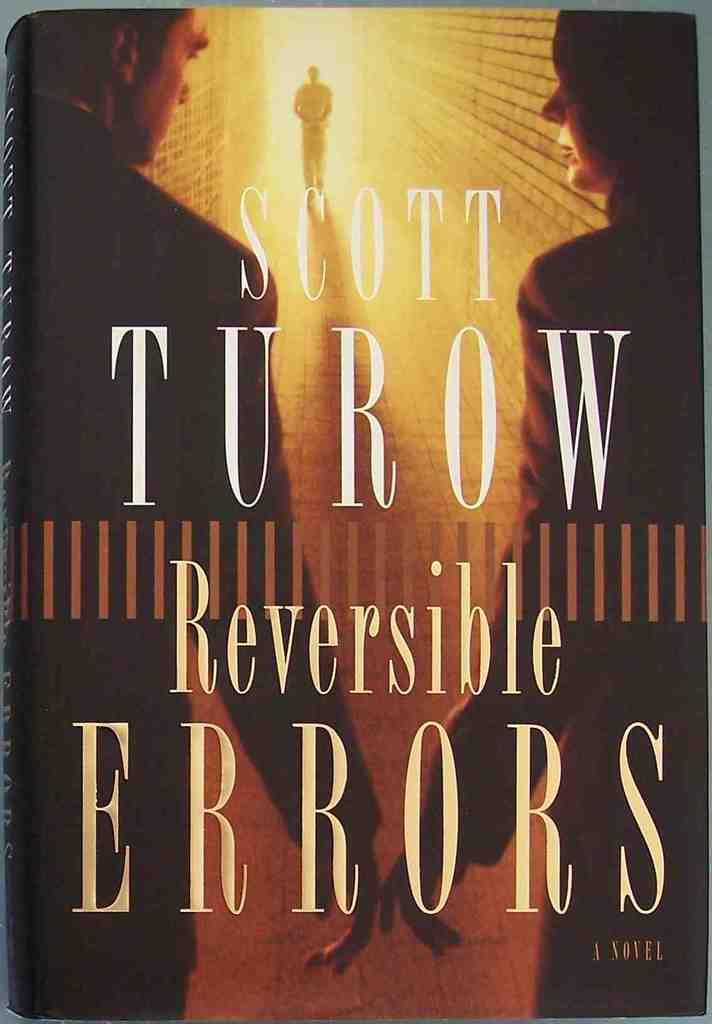Provide a one-sentence caption for the provided image. Three people are seen on the cover of Reversible Errors by Scott Turow. 